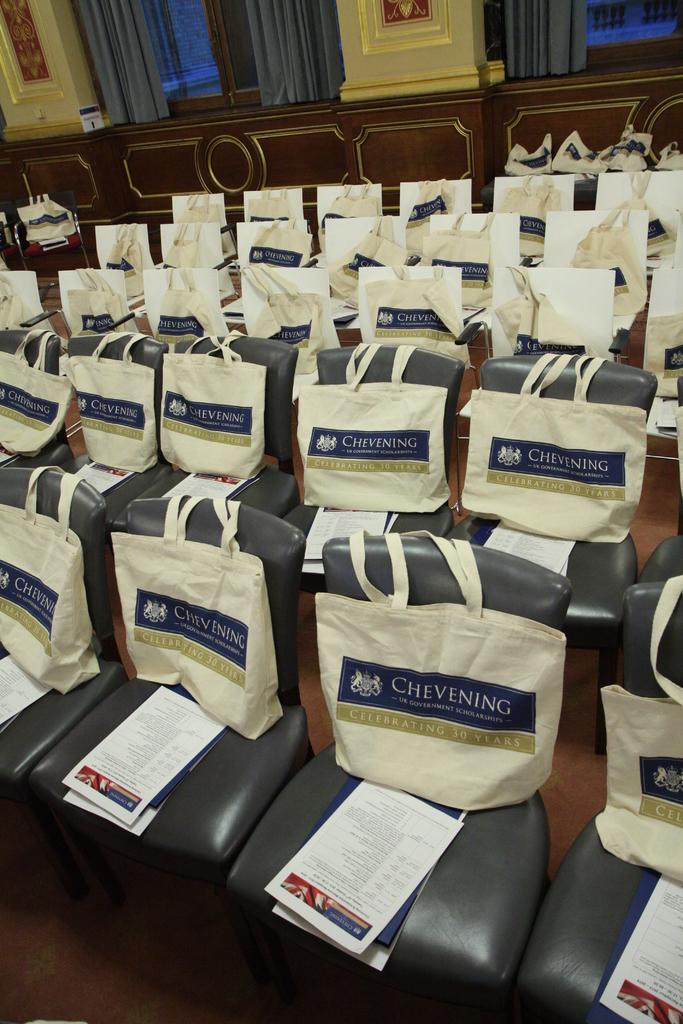What type of furniture is present in the image? There are chairs in the image. What is placed on the chairs? There are bags and papers on the chairs. Where are the windows located in the image? The windows are at the top of the image. What is the windows' position in relation to the wall? The windows are on a wall. What is used to cover the windows? The windows are covered with curtains. What type of toys can be seen supporting the bags on the chairs? There are no toys present in the image, and the bags are not being supported by any objects. 